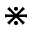Convert formula to latex. <formula><loc_0><loc_0><loc_500><loc_500>\divideontimes</formula> 